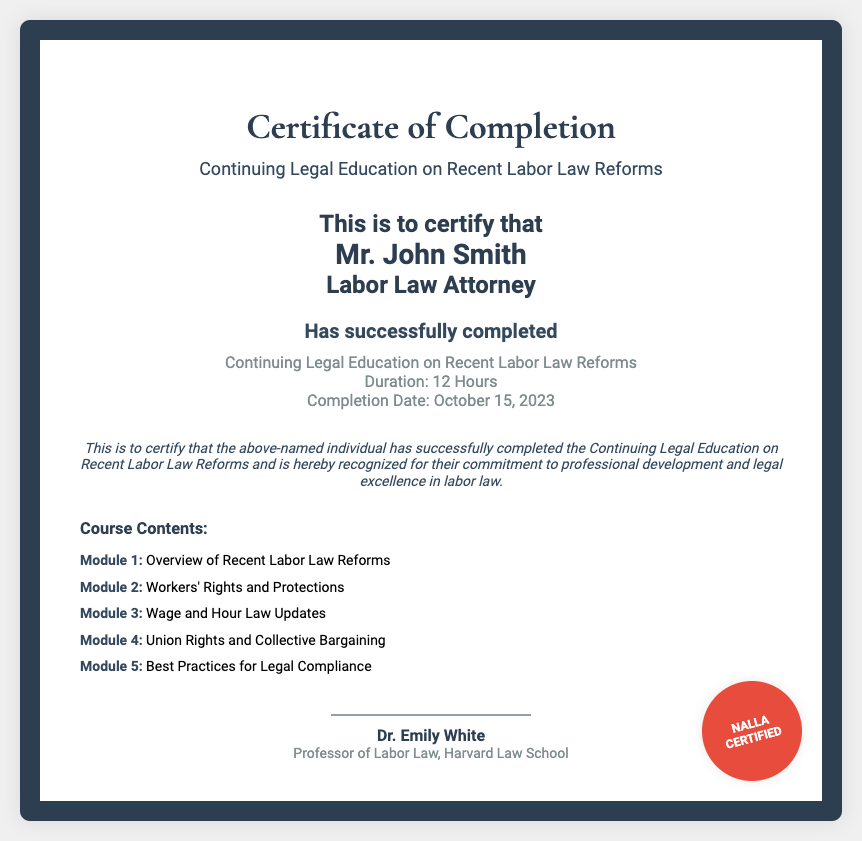What is the title of the certificate? The title can be found at the top of the certificate, representing what the certificate is for.
Answer: Certificate of Completion Who is the recipient of the certificate? The recipient's name is prominently displayed in the body of the certificate.
Answer: Mr. John Smith How many hours is the course duration? The duration of the course is indicated in the course details section.
Answer: 12 Hours What is the completion date of the course? The completion date is mentioned in the course info part of the document.
Answer: October 15, 2023 What is the first module of the course contents? The course contents list the modules of the course starting from Module 1.
Answer: Overview of Recent Labor Law Reforms Who is the instructor of the course? The instructor’s name is given below the signature line on the certificate.
Answer: Dr. Emily White What is the seal on the certificate identified as? The seal is shown at the bottom right corner of the certificate and denotes certification.
Answer: NALLA CERTIFIED What is the significance of this certificate? The certification statement explains the purpose of the document in recognizing the individual's achievement.
Answer: Professional development and legal excellence in labor law What is the document type? Understanding the nature of the document can be derived from its title and structure.
Answer: Certificate 